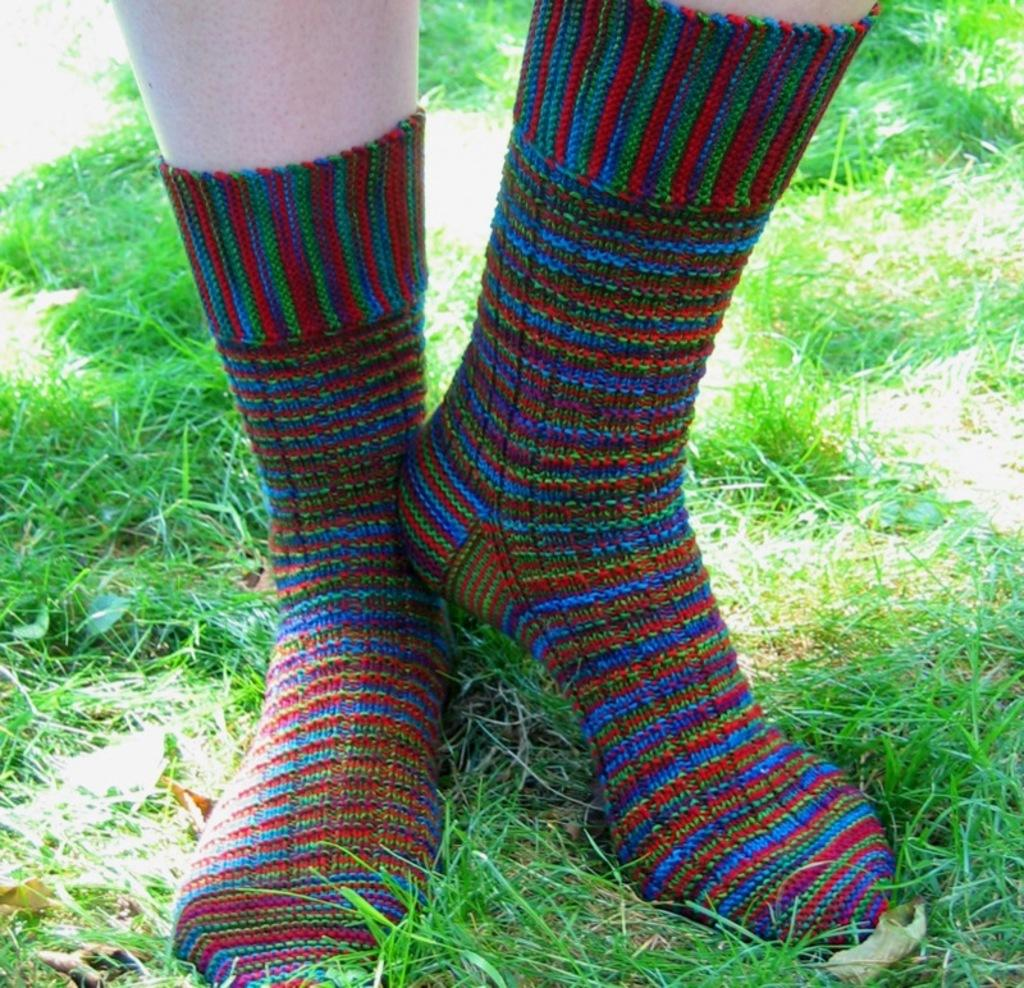What is present in the image? There is a person in the image. What is the person wearing? The person is wearing shoes. Where is the person standing? The person is standing on the grass. What is the grass situated on? The grass is on the ground. What can be seen in the background of the image? The background includes grass on the ground. What type of medical advice does the person in the image give to the doctor? There is no doctor present in the image, so the person cannot give any medical advice. 